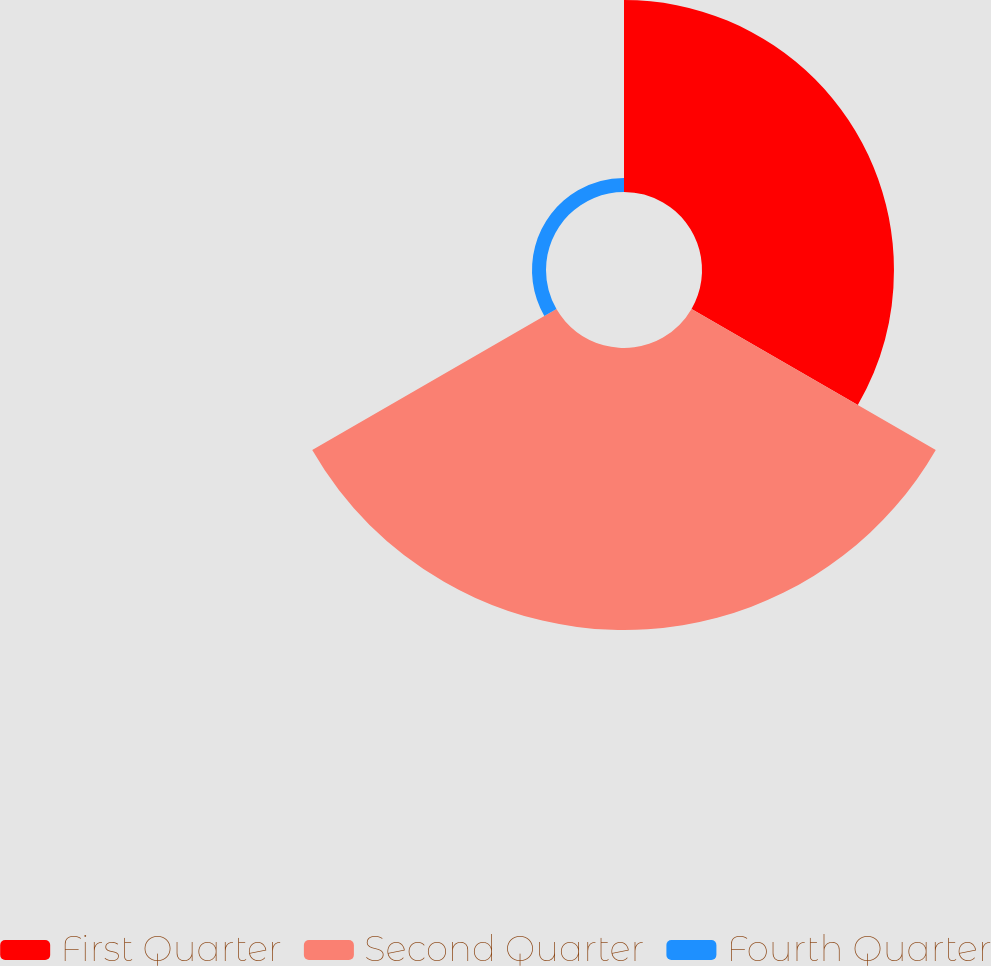<chart> <loc_0><loc_0><loc_500><loc_500><pie_chart><fcel>First Quarter<fcel>Second Quarter<fcel>Fourth Quarter<nl><fcel>39.34%<fcel>57.79%<fcel>2.87%<nl></chart> 